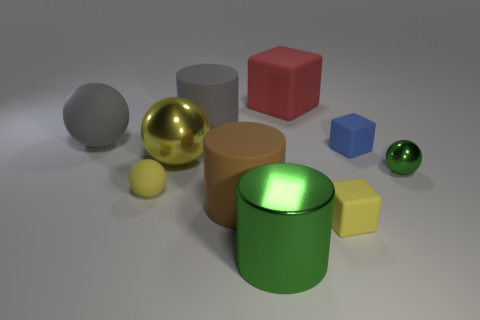Subtract 2 balls. How many balls are left? 2 Subtract all spheres. How many objects are left? 6 Add 6 big green objects. How many big green objects exist? 7 Subtract 1 yellow blocks. How many objects are left? 9 Subtract all blue rubber spheres. Subtract all big blocks. How many objects are left? 9 Add 9 red objects. How many red objects are left? 10 